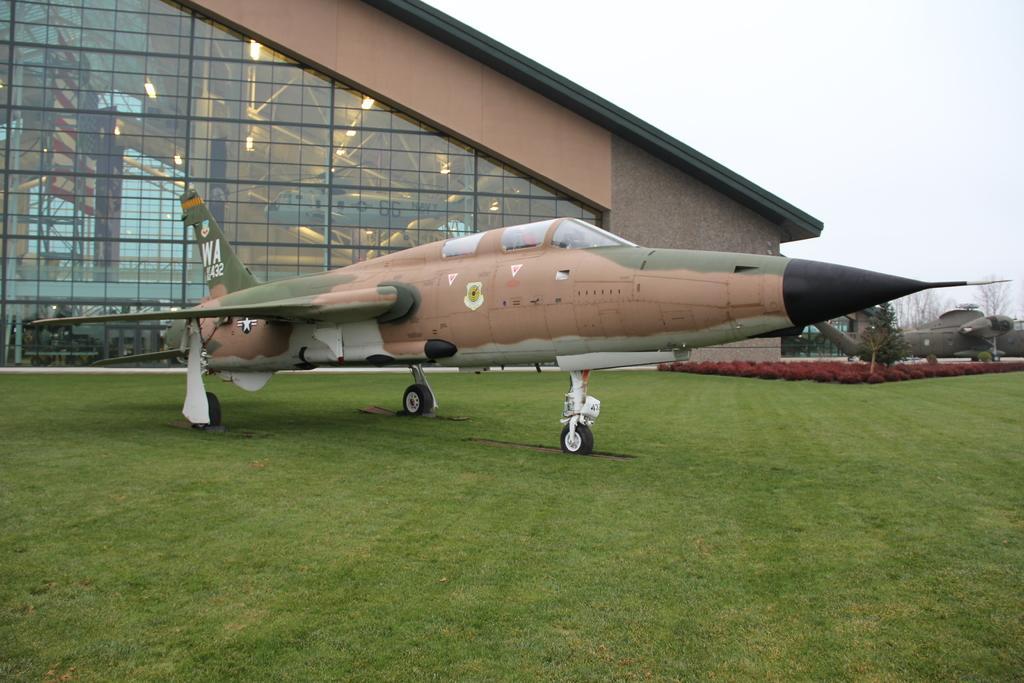Describe this image in one or two sentences. This picture shows couple of fighter jet planes and trees and a building and from the glasses of the building we see a plane and a flag and we see a cloudy sky and grass on the ground. 